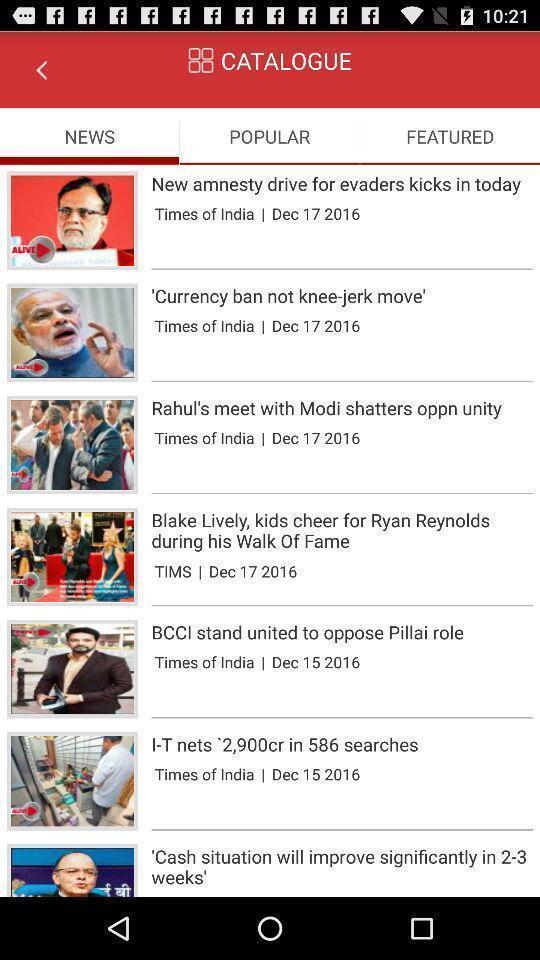Tell me about the visual elements in this screen capture. Page showing news. 